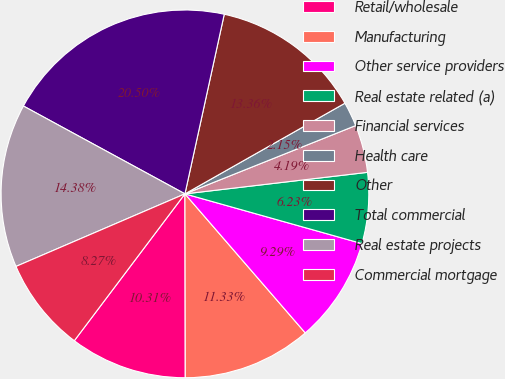Convert chart to OTSL. <chart><loc_0><loc_0><loc_500><loc_500><pie_chart><fcel>Retail/wholesale<fcel>Manufacturing<fcel>Other service providers<fcel>Real estate related (a)<fcel>Financial services<fcel>Health care<fcel>Other<fcel>Total commercial<fcel>Real estate projects<fcel>Commercial mortgage<nl><fcel>10.31%<fcel>11.33%<fcel>9.29%<fcel>6.23%<fcel>4.19%<fcel>2.15%<fcel>13.37%<fcel>20.51%<fcel>14.39%<fcel>8.27%<nl></chart> 